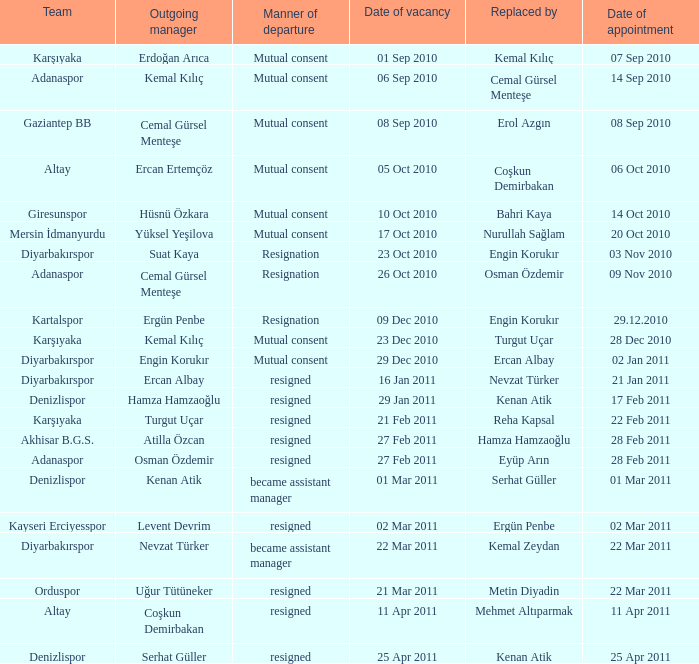When did the vacancy for kartalspor's manager position occur? 09 Dec 2010. 